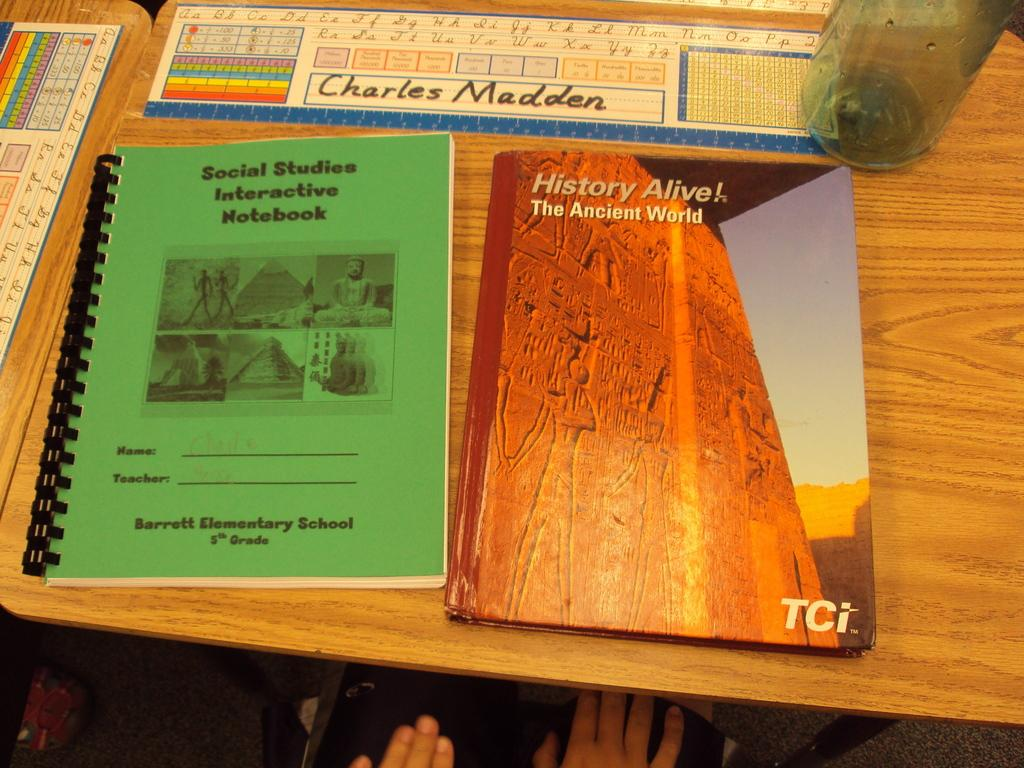<image>
Write a terse but informative summary of the picture. A desk with two school books on it has the name Charles Madden written on a learning chart. 